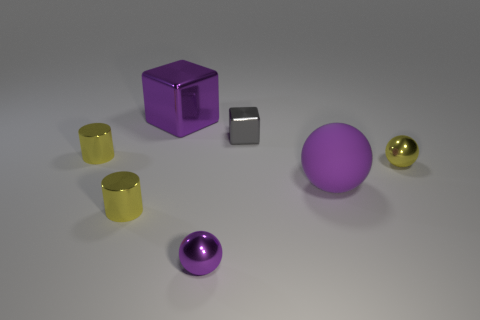Subtract all metallic spheres. How many spheres are left? 1 Subtract all balls. How many objects are left? 4 Subtract all purple blocks. How many blocks are left? 1 Subtract all large gray objects. Subtract all purple things. How many objects are left? 4 Add 4 small cylinders. How many small cylinders are left? 6 Add 4 yellow shiny balls. How many yellow shiny balls exist? 5 Add 1 tiny gray matte spheres. How many objects exist? 8 Subtract 0 brown balls. How many objects are left? 7 Subtract all green cylinders. Subtract all green balls. How many cylinders are left? 2 Subtract all red cylinders. How many brown cubes are left? 0 